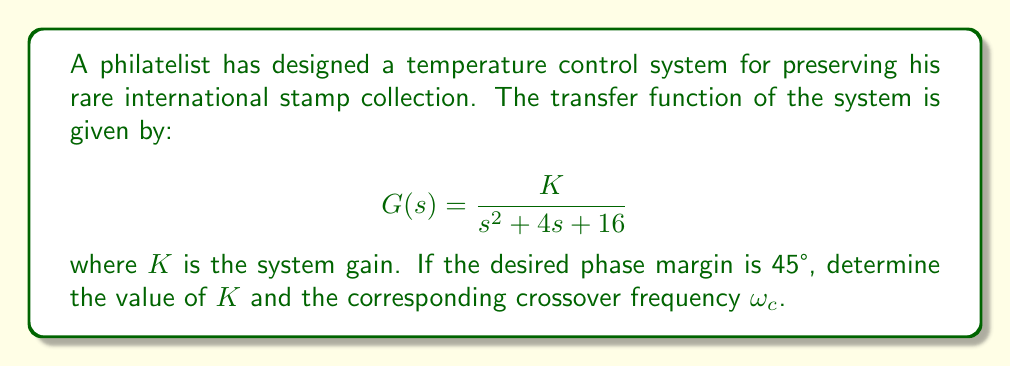Can you answer this question? To solve this problem, we'll follow these steps:

1) The phase margin of 45° means that at the crossover frequency $\omega_c$, the phase angle of $G(j\omega)$ should be -135° (since 180° - 45° = 135°).

2) For the given transfer function, the phase angle is:

   $$\angle G(j\omega) = -\tan^{-1}\left(\frac{2\omega}{\omega^2 - 16}\right) - \tan^{-1}\left(\frac{\omega}{4}\right)$$

3) At $\omega_c$, this should equal -135°. We can solve this equation numerically, which gives us:

   $$\omega_c \approx 3.46 \text{ rad/s}$$

4) Now that we know $\omega_c$, we can find $K$. At the crossover frequency, the magnitude of $G(j\omega)$ should be 1:

   $$|G(j\omega_c)| = \frac{K}{\sqrt{(\omega_c^2-16)^2 + (4\omega_c)^2}} = 1$$

5) Substituting $\omega_c = 3.46$:

   $$\frac{K}{\sqrt{(3.46^2-16)^2 + (4 \cdot 3.46)^2}} = 1$$

6) Solving for $K$:

   $$K = \sqrt{(3.46^2-16)^2 + (4 \cdot 3.46)^2} \approx 13.84$$

This value of $K$ ensures that the system has a phase margin of 45° at the crossover frequency of 3.46 rad/s.
Answer: $K \approx 13.84$, $\omega_c \approx 3.46 \text{ rad/s}$ 